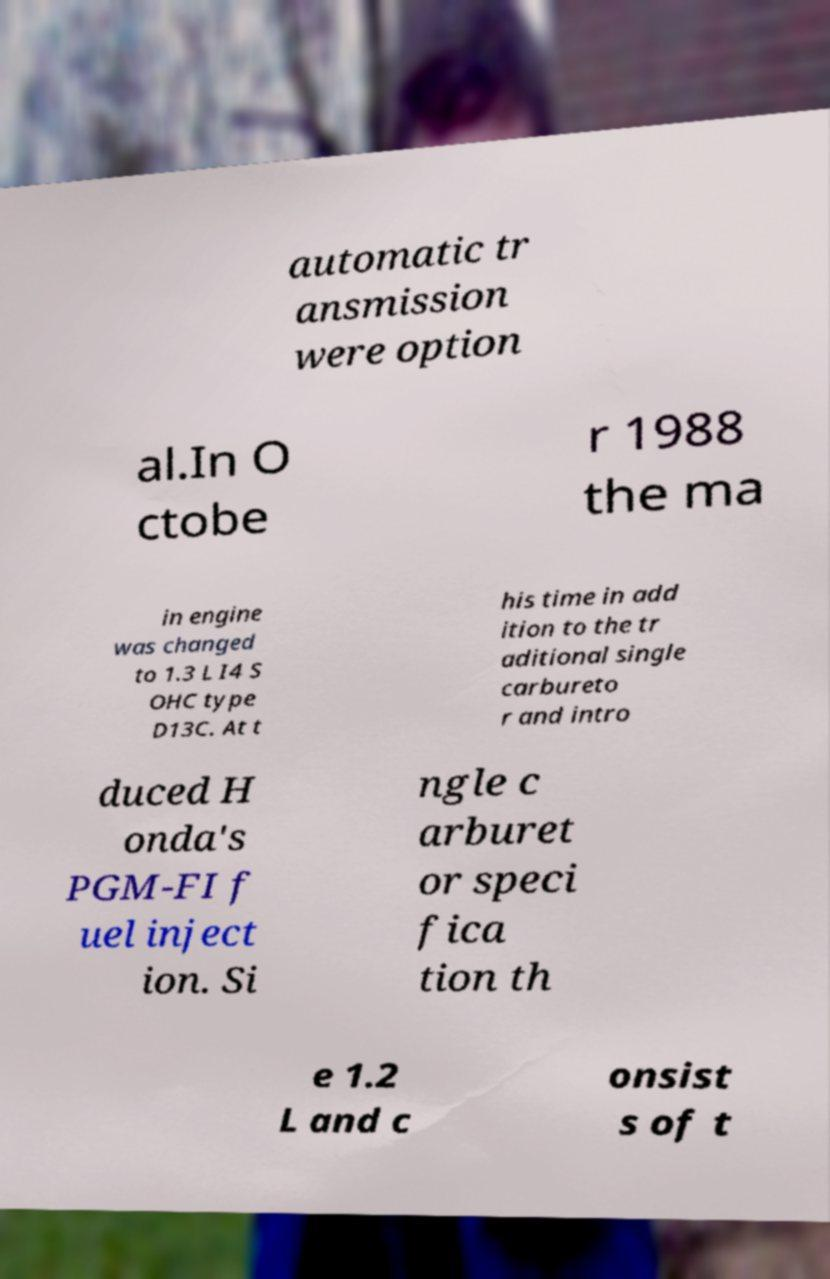Can you read and provide the text displayed in the image?This photo seems to have some interesting text. Can you extract and type it out for me? automatic tr ansmission were option al.In O ctobe r 1988 the ma in engine was changed to 1.3 L I4 S OHC type D13C. At t his time in add ition to the tr aditional single carbureto r and intro duced H onda's PGM-FI f uel inject ion. Si ngle c arburet or speci fica tion th e 1.2 L and c onsist s of t 